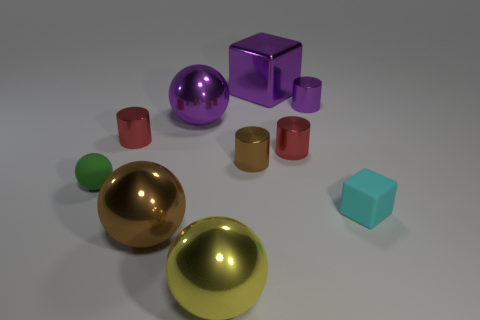Subtract 2 cylinders. How many cylinders are left? 2 Subtract all small green balls. How many balls are left? 3 Subtract all brown cylinders. How many cylinders are left? 3 Subtract all blue balls. Subtract all green blocks. How many balls are left? 4 Subtract all cylinders. How many objects are left? 6 Add 6 large purple metal blocks. How many large purple metal blocks exist? 7 Subtract 1 purple balls. How many objects are left? 9 Subtract all tiny metallic balls. Subtract all tiny green spheres. How many objects are left? 9 Add 6 red metal things. How many red metal things are left? 8 